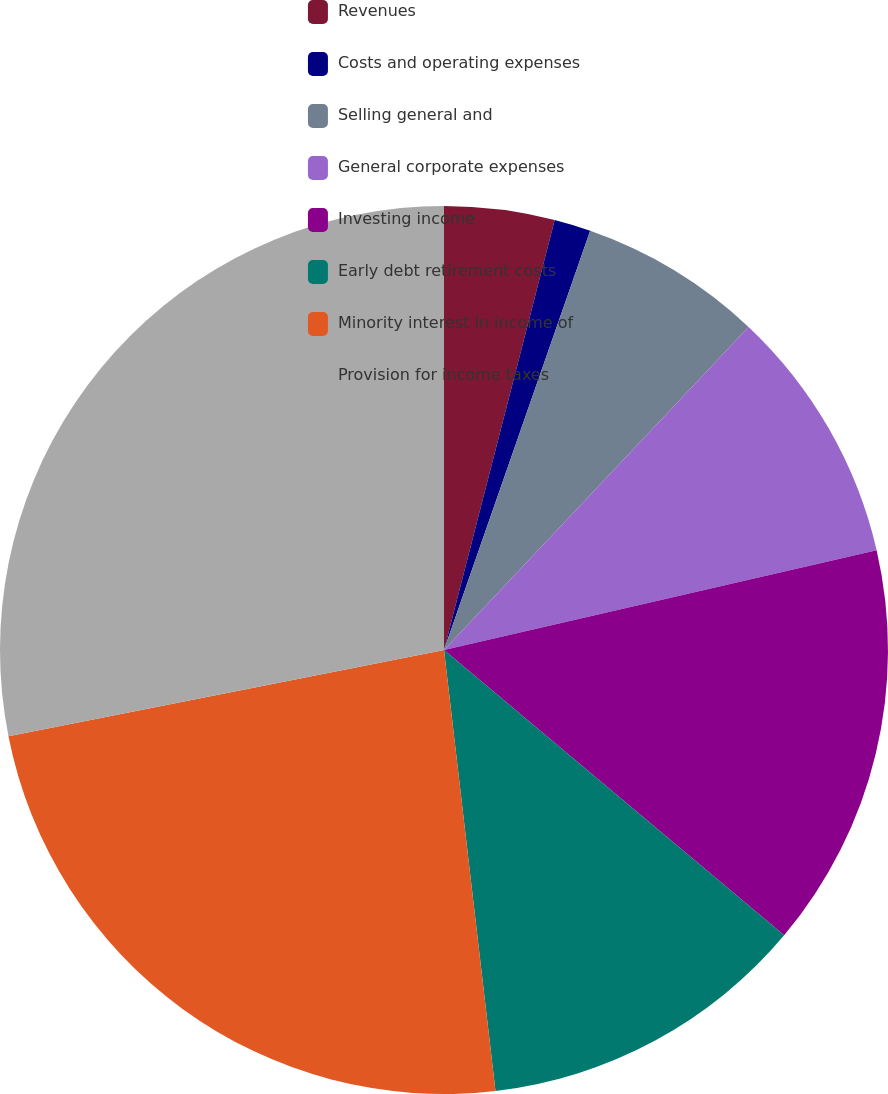Convert chart. <chart><loc_0><loc_0><loc_500><loc_500><pie_chart><fcel>Revenues<fcel>Costs and operating expenses<fcel>Selling general and<fcel>General corporate expenses<fcel>Investing income<fcel>Early debt retirement costs<fcel>Minority interest in income of<fcel>Provision for income taxes<nl><fcel>4.01%<fcel>1.33%<fcel>6.69%<fcel>9.36%<fcel>14.72%<fcel>12.04%<fcel>23.74%<fcel>28.11%<nl></chart> 